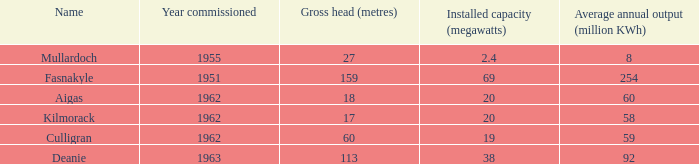What is the Year Commissioned of the power stationo with a Gross head of less than 18? 1962.0. 